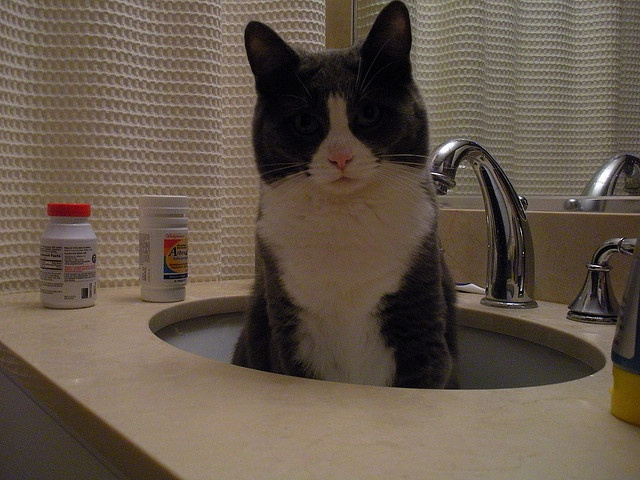Describe the objects in this image and their specific colors. I can see cat in gray, black, and maroon tones, sink in gray and black tones, bottle in gray and maroon tones, and bottle in gray, maroon, and black tones in this image. 